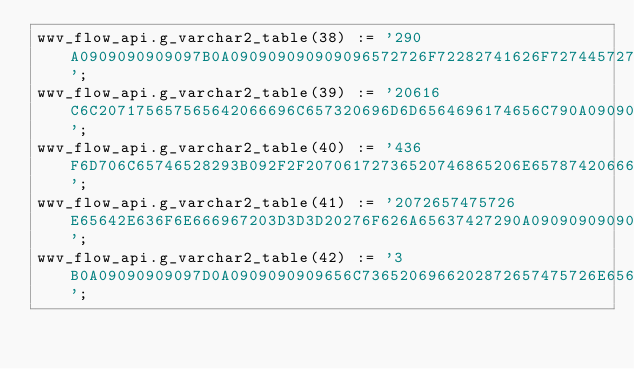Convert code to text. <code><loc_0><loc_0><loc_500><loc_500><_SQL_>wwv_flow_api.g_varchar2_table(38) := '290A0909090909097B0A090909090909096572726F72282741626F72744572726F72272C20662E66696C652C20662E696E707574456C656D2C2072657475726E65642E726561736F6E293B0A0909090909090972657475726E3B092F2F2041626F727473';
wwv_flow_api.g_varchar2_table(39) := '20616C6C207175657565642066696C657320696D6D6564696174656C790A0909090909097D0A090909090909656C7365206966202872657475726E65642E616374696F6E203D3D3D2027736B697027290A0909090909097B0A0909090909090966696C65';
wwv_flow_api.g_varchar2_table(40) := '436F6D706C65746528293B092F2F20706172736520746865206E6578742066696C6520696E207468652071756575652C20696620616E790A0909090909090972657475726E3B0A0909090909097D0A090909090909656C73652069662028747970656F66';
wwv_flow_api.g_varchar2_table(41) := '2072657475726E65642E636F6E666967203D3D3D20276F626A65637427290A09090909090909662E696E7374616E6365436F6E666967203D20242E657874656E6428662E696E7374616E6365436F6E6669672C2072657475726E65642E636F6E66696729';
wwv_flow_api.g_varchar2_table(42) := '3B0A09090909097D0A0909090909656C7365206966202872657475726E6564203D3D3D2027736B697027290A09090909097B0A09090909090966696C65436F6D706C65746528293B092F2F20706172736520746865206E6578742066696C6520696E2074';</code> 